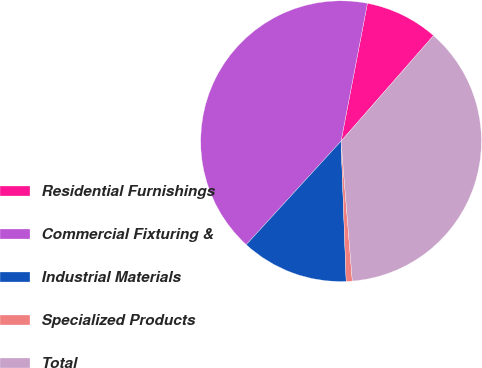Convert chart to OTSL. <chart><loc_0><loc_0><loc_500><loc_500><pie_chart><fcel>Residential Furnishings<fcel>Commercial Fixturing &<fcel>Industrial Materials<fcel>Specialized Products<fcel>Total<nl><fcel>8.44%<fcel>41.21%<fcel>12.38%<fcel>0.7%<fcel>37.27%<nl></chart> 